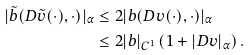Convert formula to latex. <formula><loc_0><loc_0><loc_500><loc_500>| \tilde { b } ( D \tilde { v } ( \cdot ) , \cdot ) | _ { \alpha } & \leq 2 | b ( D v ( \cdot ) , \cdot ) | _ { \alpha } \\ & \leq 2 | b | _ { C ^ { 1 } } \left ( 1 + | D v | _ { \alpha } \right ) .</formula> 